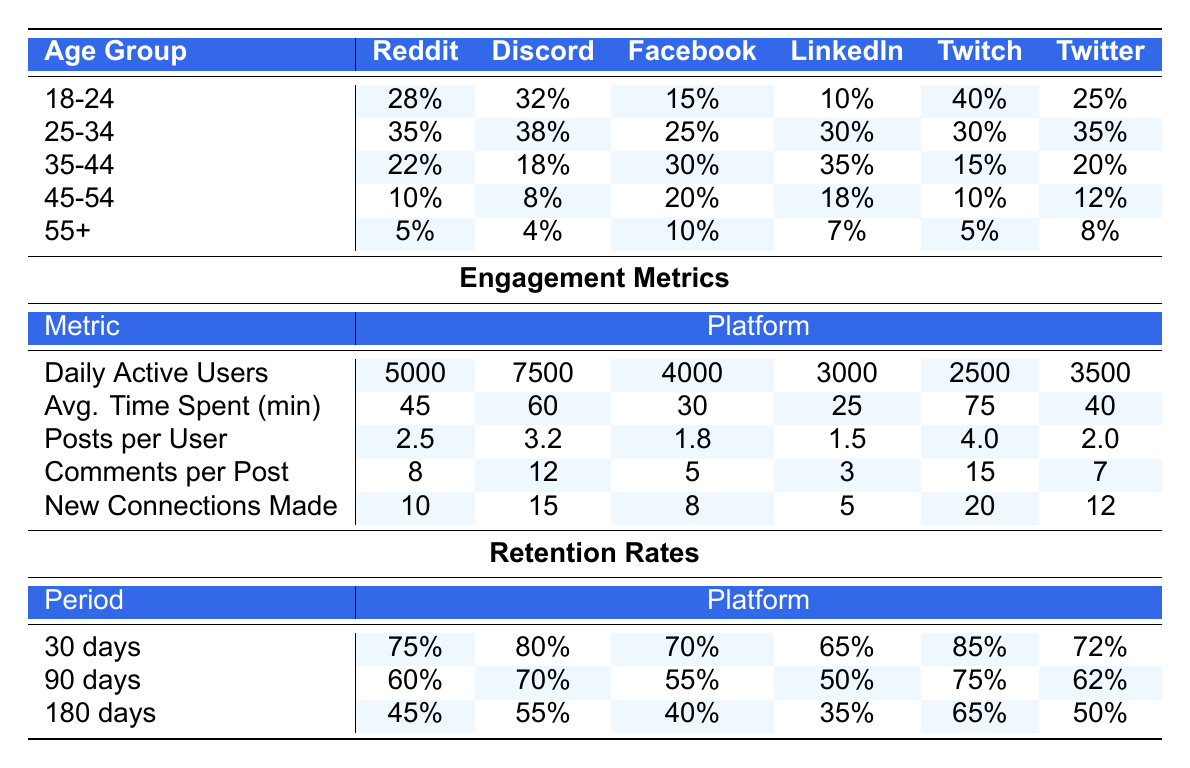What percentage of new members aged 45-54 joined Discord? Looking at the age group 45-54 in the Discord column, the value is 8%.
Answer: 8% Which age group has the highest percentage of new members on Twitch? In the Twitch column, the highest percentage is from the age group 18-24 with 40%.
Answer: 40% What is the average retention rate for new members across all platforms after 30 days? For the 30-day retention rates: (75 + 80 + 70 + 65 + 85 + 72) / 6 = 74.17%.
Answer: 74.17% On which platform is the average time spent the highest for the age group 25-34? The average time spent for the age group 25-34 shows 60 minutes on Discord, which is the highest compared to other platforms.
Answer: Discord What is the total number of daily active users on Facebook Groups? The daily active users for Facebook Groups is 4000; this is a direct lookup in the table.
Answer: 4000 Do more new members aged 18-24 join Reddit or Discord? For the age group 18-24, more members join Discord at 32% compared to 28% for Reddit.
Answer: Discord What is the difference in new connections made between the highest and lowest age groups on Twitch? The age group 18-24 has 20 new connections while the 55+ age group has 5 new connections; the difference is 20 - 5 = 15.
Answer: 15 Which platform has the lowest retention rate after 180 days? The lowest retention rate after 180 days is for Facebook Groups at 40%.
Answer: Facebook Groups Calculate the total number of new members aged 35-44 across all platforms. The totals for the age group 35-44 are: Reddit (22%) + Discord (18%) + Facebook Groups (30%) + LinkedIn (35%) + Twitch (15%) + Twitter (20%) = 140%.
Answer: 140% Is the engagement in terms of posts per user higher for the age group 25-34 on Discord or Reddit? The posts per user for Discord is 3.2, while for Reddit, it is 2.5, making it higher on Discord.
Answer: Discord Which age group has the highest retention rate at 90 days? The highest retention rate at 90 days is for those aged 18-24 with 70% on Discord.
Answer: 70% 